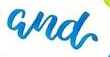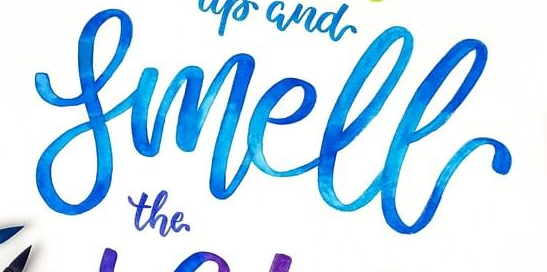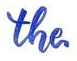Read the text content from these images in order, separated by a semicolon. and; Smell; the 